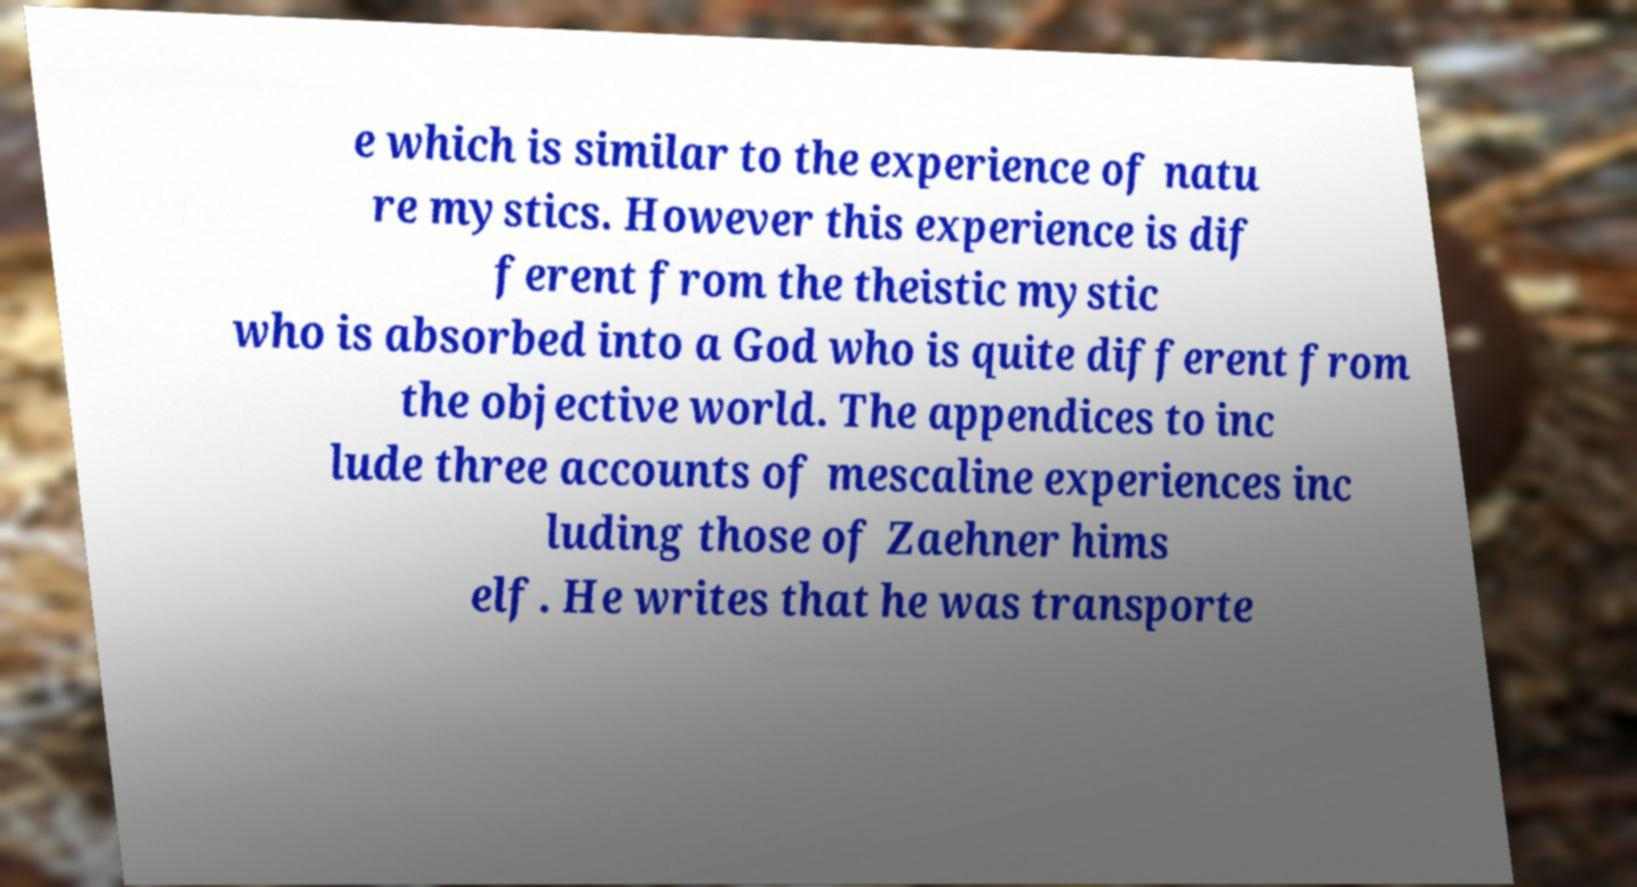For documentation purposes, I need the text within this image transcribed. Could you provide that? e which is similar to the experience of natu re mystics. However this experience is dif ferent from the theistic mystic who is absorbed into a God who is quite different from the objective world. The appendices to inc lude three accounts of mescaline experiences inc luding those of Zaehner hims elf. He writes that he was transporte 